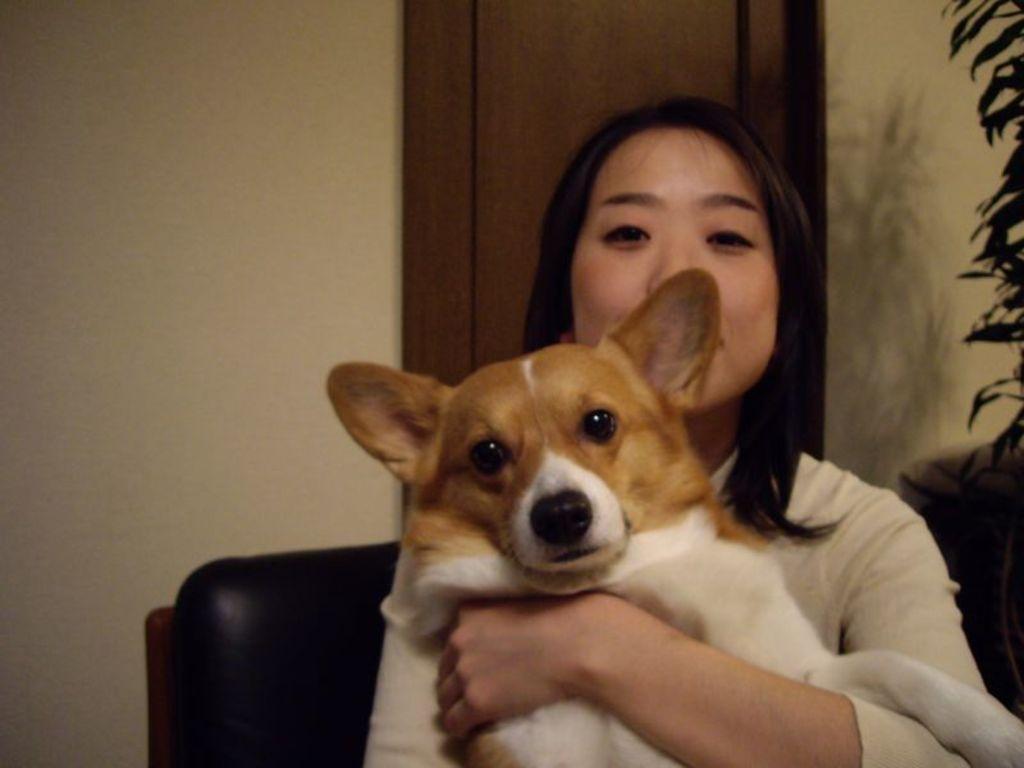In one or two sentences, can you explain what this image depicts? This person sitting on the chair and holding dog. On the background we can see wall. 